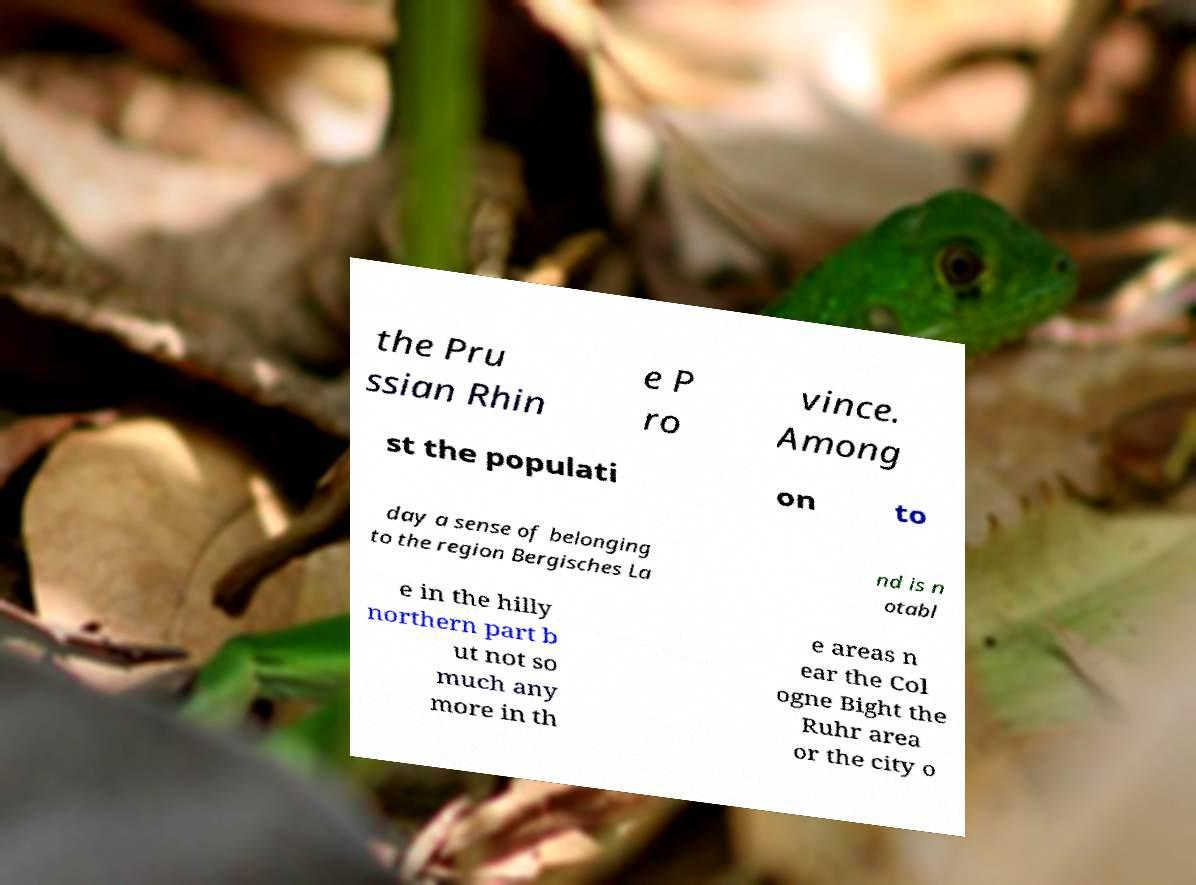Please read and relay the text visible in this image. What does it say? the Pru ssian Rhin e P ro vince. Among st the populati on to day a sense of belonging to the region Bergisches La nd is n otabl e in the hilly northern part b ut not so much any more in th e areas n ear the Col ogne Bight the Ruhr area or the city o 